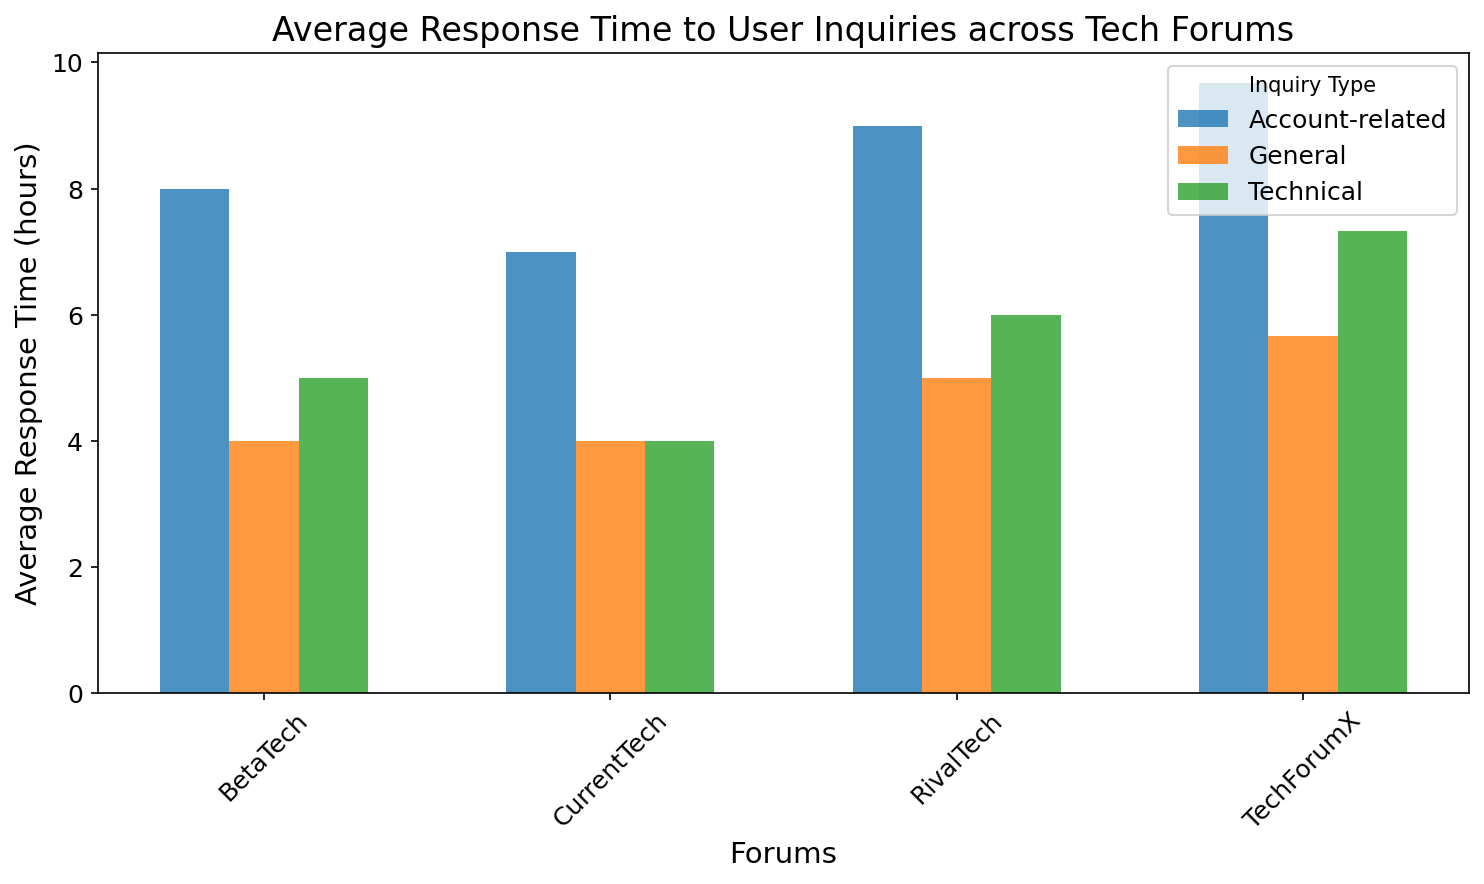What is the average response time for technical inquiries in RivalTech? To find the average response time for technical inquiries, locate the bar representing RivalTech and technical inquiries.
Answer: 6 How does the average response time for technical inquiries in CurrentTech compare to BetaTech? Look at the bars for technical inquiries for both CurrentTech and BetaTech. Compare the height of the bars.
Answer: CurrentTech is lower Which forum has the shortest average response time for general inquiries? Locate the bars for general inquiries across all forums and identify the shortest one.
Answer: BetaTech What is the difference in the average response time between technical and account-related inquiries in TechForumX? Locate the bars for TechForumX, find the heights for technical and account-related inquiries, and then calculate the difference.
Answer: 2 Compare the average response time for account-related inquiries between RivalTech and CurrentTech. Which is greater? Look at the bars for account-related inquiries for both RivalTech and CurrentTech. Identify which bar is taller.
Answer: RivalTech What is the average response time for general inquiries across all forums? Calculate the average height of the bars representing general inquiries for all forums.
Answer: 4.5 By how much does the average response time for technical inquiries in BetaTech exceed that of CurrentTech? Locate the bars for technical inquiries in both BetaTech and CurrentTech. Subtract the height of the CurrentTech bar from the BetaTech bar.
Answer: 1.5 Which forum has the highest average response time for account-related inquiries? Identify the bar with the largest height among those representing account-related inquiries across all forums.
Answer: TechForumX Are the average response times for general inquiries the same for RivalTech and TechForumX? Compare the heights of the bars for general inquiries for both RivalTech and TechForumX. Assess if they are equal.
Answer: No 